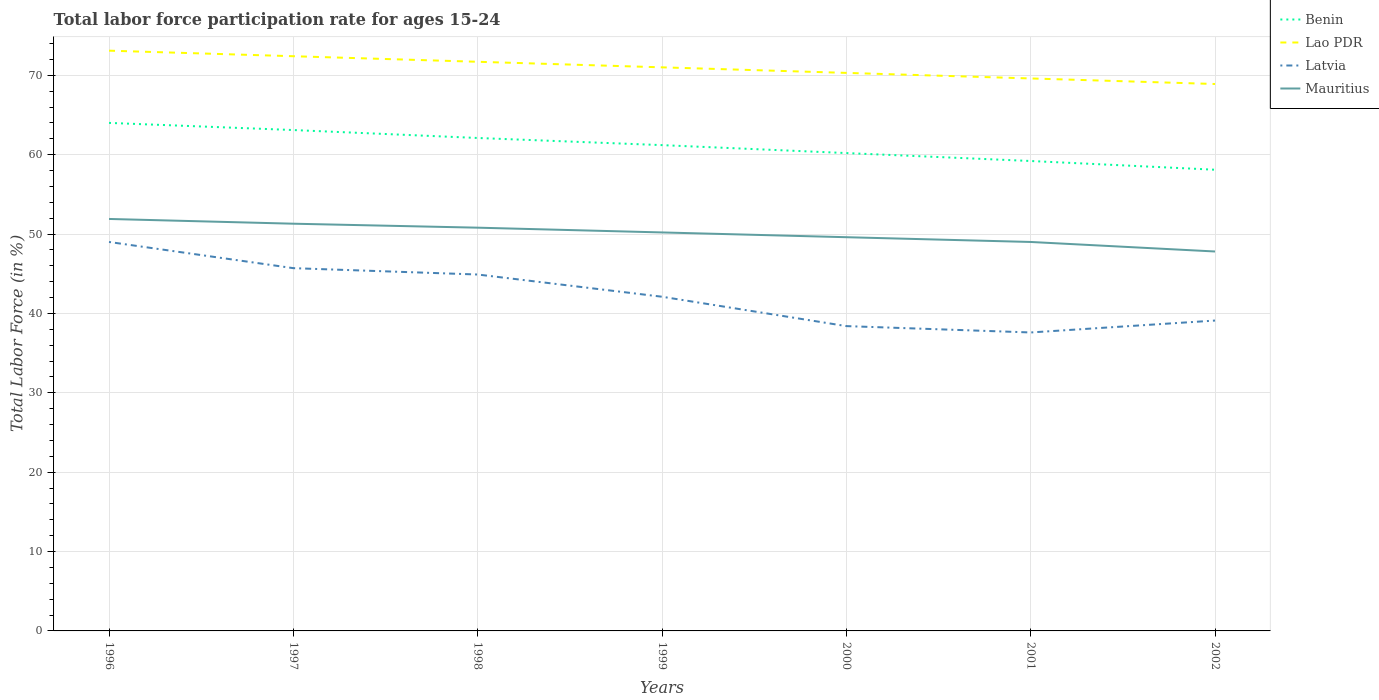How many different coloured lines are there?
Keep it short and to the point. 4. Is the number of lines equal to the number of legend labels?
Offer a terse response. Yes. Across all years, what is the maximum labor force participation rate in Latvia?
Ensure brevity in your answer.  37.6. What is the total labor force participation rate in Latvia in the graph?
Make the answer very short. 3. What is the difference between the highest and the second highest labor force participation rate in Benin?
Offer a terse response. 5.9. What is the difference between the highest and the lowest labor force participation rate in Latvia?
Offer a terse response. 3. Is the labor force participation rate in Lao PDR strictly greater than the labor force participation rate in Mauritius over the years?
Your answer should be very brief. No. How many lines are there?
Provide a succinct answer. 4. What is the difference between two consecutive major ticks on the Y-axis?
Keep it short and to the point. 10. Does the graph contain any zero values?
Make the answer very short. No. Does the graph contain grids?
Provide a succinct answer. Yes. How many legend labels are there?
Make the answer very short. 4. How are the legend labels stacked?
Your response must be concise. Vertical. What is the title of the graph?
Keep it short and to the point. Total labor force participation rate for ages 15-24. Does "Serbia" appear as one of the legend labels in the graph?
Your answer should be very brief. No. What is the label or title of the Y-axis?
Make the answer very short. Total Labor Force (in %). What is the Total Labor Force (in %) of Lao PDR in 1996?
Provide a succinct answer. 73.1. What is the Total Labor Force (in %) of Latvia in 1996?
Offer a very short reply. 49. What is the Total Labor Force (in %) in Mauritius in 1996?
Give a very brief answer. 51.9. What is the Total Labor Force (in %) of Benin in 1997?
Your response must be concise. 63.1. What is the Total Labor Force (in %) of Lao PDR in 1997?
Make the answer very short. 72.4. What is the Total Labor Force (in %) of Latvia in 1997?
Give a very brief answer. 45.7. What is the Total Labor Force (in %) of Mauritius in 1997?
Offer a terse response. 51.3. What is the Total Labor Force (in %) in Benin in 1998?
Your response must be concise. 62.1. What is the Total Labor Force (in %) in Lao PDR in 1998?
Offer a terse response. 71.7. What is the Total Labor Force (in %) of Latvia in 1998?
Keep it short and to the point. 44.9. What is the Total Labor Force (in %) of Mauritius in 1998?
Your response must be concise. 50.8. What is the Total Labor Force (in %) of Benin in 1999?
Give a very brief answer. 61.2. What is the Total Labor Force (in %) of Latvia in 1999?
Provide a short and direct response. 42.1. What is the Total Labor Force (in %) of Mauritius in 1999?
Keep it short and to the point. 50.2. What is the Total Labor Force (in %) in Benin in 2000?
Offer a very short reply. 60.2. What is the Total Labor Force (in %) of Lao PDR in 2000?
Keep it short and to the point. 70.3. What is the Total Labor Force (in %) in Latvia in 2000?
Keep it short and to the point. 38.4. What is the Total Labor Force (in %) in Mauritius in 2000?
Give a very brief answer. 49.6. What is the Total Labor Force (in %) of Benin in 2001?
Your answer should be very brief. 59.2. What is the Total Labor Force (in %) in Lao PDR in 2001?
Give a very brief answer. 69.6. What is the Total Labor Force (in %) of Latvia in 2001?
Provide a short and direct response. 37.6. What is the Total Labor Force (in %) in Mauritius in 2001?
Your answer should be very brief. 49. What is the Total Labor Force (in %) of Benin in 2002?
Provide a succinct answer. 58.1. What is the Total Labor Force (in %) in Lao PDR in 2002?
Provide a succinct answer. 68.9. What is the Total Labor Force (in %) in Latvia in 2002?
Provide a succinct answer. 39.1. What is the Total Labor Force (in %) in Mauritius in 2002?
Ensure brevity in your answer.  47.8. Across all years, what is the maximum Total Labor Force (in %) of Benin?
Give a very brief answer. 64. Across all years, what is the maximum Total Labor Force (in %) in Lao PDR?
Your response must be concise. 73.1. Across all years, what is the maximum Total Labor Force (in %) of Mauritius?
Provide a short and direct response. 51.9. Across all years, what is the minimum Total Labor Force (in %) of Benin?
Offer a terse response. 58.1. Across all years, what is the minimum Total Labor Force (in %) in Lao PDR?
Make the answer very short. 68.9. Across all years, what is the minimum Total Labor Force (in %) in Latvia?
Give a very brief answer. 37.6. Across all years, what is the minimum Total Labor Force (in %) of Mauritius?
Make the answer very short. 47.8. What is the total Total Labor Force (in %) of Benin in the graph?
Ensure brevity in your answer.  427.9. What is the total Total Labor Force (in %) of Lao PDR in the graph?
Offer a very short reply. 497. What is the total Total Labor Force (in %) in Latvia in the graph?
Offer a terse response. 296.8. What is the total Total Labor Force (in %) of Mauritius in the graph?
Provide a short and direct response. 350.6. What is the difference between the Total Labor Force (in %) of Benin in 1996 and that in 1998?
Ensure brevity in your answer.  1.9. What is the difference between the Total Labor Force (in %) of Lao PDR in 1996 and that in 1998?
Provide a short and direct response. 1.4. What is the difference between the Total Labor Force (in %) of Latvia in 1996 and that in 1998?
Make the answer very short. 4.1. What is the difference between the Total Labor Force (in %) of Benin in 1996 and that in 1999?
Keep it short and to the point. 2.8. What is the difference between the Total Labor Force (in %) in Mauritius in 1996 and that in 1999?
Ensure brevity in your answer.  1.7. What is the difference between the Total Labor Force (in %) in Benin in 1996 and that in 2000?
Provide a succinct answer. 3.8. What is the difference between the Total Labor Force (in %) in Mauritius in 1996 and that in 2000?
Your answer should be compact. 2.3. What is the difference between the Total Labor Force (in %) in Benin in 1997 and that in 1998?
Your answer should be very brief. 1. What is the difference between the Total Labor Force (in %) in Mauritius in 1997 and that in 1998?
Offer a terse response. 0.5. What is the difference between the Total Labor Force (in %) of Benin in 1997 and that in 1999?
Keep it short and to the point. 1.9. What is the difference between the Total Labor Force (in %) in Latvia in 1997 and that in 1999?
Provide a succinct answer. 3.6. What is the difference between the Total Labor Force (in %) of Mauritius in 1997 and that in 1999?
Ensure brevity in your answer.  1.1. What is the difference between the Total Labor Force (in %) of Benin in 1997 and that in 2000?
Give a very brief answer. 2.9. What is the difference between the Total Labor Force (in %) in Lao PDR in 1997 and that in 2001?
Give a very brief answer. 2.8. What is the difference between the Total Labor Force (in %) in Benin in 1997 and that in 2002?
Ensure brevity in your answer.  5. What is the difference between the Total Labor Force (in %) of Benin in 1998 and that in 1999?
Ensure brevity in your answer.  0.9. What is the difference between the Total Labor Force (in %) in Mauritius in 1998 and that in 1999?
Give a very brief answer. 0.6. What is the difference between the Total Labor Force (in %) in Lao PDR in 1998 and that in 2000?
Ensure brevity in your answer.  1.4. What is the difference between the Total Labor Force (in %) of Benin in 1998 and that in 2002?
Your response must be concise. 4. What is the difference between the Total Labor Force (in %) of Lao PDR in 1998 and that in 2002?
Offer a very short reply. 2.8. What is the difference between the Total Labor Force (in %) of Mauritius in 1998 and that in 2002?
Provide a short and direct response. 3. What is the difference between the Total Labor Force (in %) of Lao PDR in 1999 and that in 2000?
Your answer should be compact. 0.7. What is the difference between the Total Labor Force (in %) in Latvia in 1999 and that in 2000?
Your response must be concise. 3.7. What is the difference between the Total Labor Force (in %) of Mauritius in 1999 and that in 2000?
Provide a short and direct response. 0.6. What is the difference between the Total Labor Force (in %) in Benin in 1999 and that in 2001?
Provide a succinct answer. 2. What is the difference between the Total Labor Force (in %) in Lao PDR in 1999 and that in 2001?
Ensure brevity in your answer.  1.4. What is the difference between the Total Labor Force (in %) in Benin in 1999 and that in 2002?
Offer a terse response. 3.1. What is the difference between the Total Labor Force (in %) in Lao PDR in 1999 and that in 2002?
Make the answer very short. 2.1. What is the difference between the Total Labor Force (in %) in Latvia in 1999 and that in 2002?
Offer a terse response. 3. What is the difference between the Total Labor Force (in %) in Benin in 2000 and that in 2001?
Ensure brevity in your answer.  1. What is the difference between the Total Labor Force (in %) in Lao PDR in 2000 and that in 2001?
Keep it short and to the point. 0.7. What is the difference between the Total Labor Force (in %) in Latvia in 2000 and that in 2001?
Provide a succinct answer. 0.8. What is the difference between the Total Labor Force (in %) in Mauritius in 2000 and that in 2002?
Your answer should be very brief. 1.8. What is the difference between the Total Labor Force (in %) in Benin in 1996 and the Total Labor Force (in %) in Lao PDR in 1997?
Make the answer very short. -8.4. What is the difference between the Total Labor Force (in %) of Lao PDR in 1996 and the Total Labor Force (in %) of Latvia in 1997?
Provide a short and direct response. 27.4. What is the difference between the Total Labor Force (in %) of Lao PDR in 1996 and the Total Labor Force (in %) of Mauritius in 1997?
Provide a succinct answer. 21.8. What is the difference between the Total Labor Force (in %) in Latvia in 1996 and the Total Labor Force (in %) in Mauritius in 1997?
Your answer should be compact. -2.3. What is the difference between the Total Labor Force (in %) in Benin in 1996 and the Total Labor Force (in %) in Latvia in 1998?
Your answer should be very brief. 19.1. What is the difference between the Total Labor Force (in %) in Lao PDR in 1996 and the Total Labor Force (in %) in Latvia in 1998?
Ensure brevity in your answer.  28.2. What is the difference between the Total Labor Force (in %) of Lao PDR in 1996 and the Total Labor Force (in %) of Mauritius in 1998?
Keep it short and to the point. 22.3. What is the difference between the Total Labor Force (in %) of Benin in 1996 and the Total Labor Force (in %) of Lao PDR in 1999?
Your answer should be compact. -7. What is the difference between the Total Labor Force (in %) in Benin in 1996 and the Total Labor Force (in %) in Latvia in 1999?
Provide a succinct answer. 21.9. What is the difference between the Total Labor Force (in %) of Lao PDR in 1996 and the Total Labor Force (in %) of Mauritius in 1999?
Your answer should be very brief. 22.9. What is the difference between the Total Labor Force (in %) in Benin in 1996 and the Total Labor Force (in %) in Latvia in 2000?
Make the answer very short. 25.6. What is the difference between the Total Labor Force (in %) in Lao PDR in 1996 and the Total Labor Force (in %) in Latvia in 2000?
Ensure brevity in your answer.  34.7. What is the difference between the Total Labor Force (in %) of Lao PDR in 1996 and the Total Labor Force (in %) of Mauritius in 2000?
Keep it short and to the point. 23.5. What is the difference between the Total Labor Force (in %) in Latvia in 1996 and the Total Labor Force (in %) in Mauritius in 2000?
Offer a terse response. -0.6. What is the difference between the Total Labor Force (in %) of Benin in 1996 and the Total Labor Force (in %) of Latvia in 2001?
Make the answer very short. 26.4. What is the difference between the Total Labor Force (in %) of Benin in 1996 and the Total Labor Force (in %) of Mauritius in 2001?
Keep it short and to the point. 15. What is the difference between the Total Labor Force (in %) in Lao PDR in 1996 and the Total Labor Force (in %) in Latvia in 2001?
Ensure brevity in your answer.  35.5. What is the difference between the Total Labor Force (in %) in Lao PDR in 1996 and the Total Labor Force (in %) in Mauritius in 2001?
Your answer should be very brief. 24.1. What is the difference between the Total Labor Force (in %) of Latvia in 1996 and the Total Labor Force (in %) of Mauritius in 2001?
Your answer should be very brief. 0. What is the difference between the Total Labor Force (in %) in Benin in 1996 and the Total Labor Force (in %) in Lao PDR in 2002?
Give a very brief answer. -4.9. What is the difference between the Total Labor Force (in %) of Benin in 1996 and the Total Labor Force (in %) of Latvia in 2002?
Your answer should be compact. 24.9. What is the difference between the Total Labor Force (in %) in Lao PDR in 1996 and the Total Labor Force (in %) in Mauritius in 2002?
Offer a terse response. 25.3. What is the difference between the Total Labor Force (in %) in Benin in 1997 and the Total Labor Force (in %) in Lao PDR in 1998?
Give a very brief answer. -8.6. What is the difference between the Total Labor Force (in %) in Lao PDR in 1997 and the Total Labor Force (in %) in Latvia in 1998?
Ensure brevity in your answer.  27.5. What is the difference between the Total Labor Force (in %) in Lao PDR in 1997 and the Total Labor Force (in %) in Mauritius in 1998?
Your answer should be very brief. 21.6. What is the difference between the Total Labor Force (in %) of Benin in 1997 and the Total Labor Force (in %) of Lao PDR in 1999?
Give a very brief answer. -7.9. What is the difference between the Total Labor Force (in %) in Benin in 1997 and the Total Labor Force (in %) in Latvia in 1999?
Give a very brief answer. 21. What is the difference between the Total Labor Force (in %) in Benin in 1997 and the Total Labor Force (in %) in Mauritius in 1999?
Your answer should be compact. 12.9. What is the difference between the Total Labor Force (in %) of Lao PDR in 1997 and the Total Labor Force (in %) of Latvia in 1999?
Provide a succinct answer. 30.3. What is the difference between the Total Labor Force (in %) in Benin in 1997 and the Total Labor Force (in %) in Latvia in 2000?
Make the answer very short. 24.7. What is the difference between the Total Labor Force (in %) in Lao PDR in 1997 and the Total Labor Force (in %) in Mauritius in 2000?
Keep it short and to the point. 22.8. What is the difference between the Total Labor Force (in %) of Benin in 1997 and the Total Labor Force (in %) of Lao PDR in 2001?
Your response must be concise. -6.5. What is the difference between the Total Labor Force (in %) of Benin in 1997 and the Total Labor Force (in %) of Latvia in 2001?
Your response must be concise. 25.5. What is the difference between the Total Labor Force (in %) of Lao PDR in 1997 and the Total Labor Force (in %) of Latvia in 2001?
Offer a very short reply. 34.8. What is the difference between the Total Labor Force (in %) of Lao PDR in 1997 and the Total Labor Force (in %) of Mauritius in 2001?
Your answer should be very brief. 23.4. What is the difference between the Total Labor Force (in %) of Latvia in 1997 and the Total Labor Force (in %) of Mauritius in 2001?
Ensure brevity in your answer.  -3.3. What is the difference between the Total Labor Force (in %) in Benin in 1997 and the Total Labor Force (in %) in Lao PDR in 2002?
Ensure brevity in your answer.  -5.8. What is the difference between the Total Labor Force (in %) of Lao PDR in 1997 and the Total Labor Force (in %) of Latvia in 2002?
Provide a short and direct response. 33.3. What is the difference between the Total Labor Force (in %) in Lao PDR in 1997 and the Total Labor Force (in %) in Mauritius in 2002?
Keep it short and to the point. 24.6. What is the difference between the Total Labor Force (in %) in Latvia in 1997 and the Total Labor Force (in %) in Mauritius in 2002?
Offer a terse response. -2.1. What is the difference between the Total Labor Force (in %) of Benin in 1998 and the Total Labor Force (in %) of Mauritius in 1999?
Keep it short and to the point. 11.9. What is the difference between the Total Labor Force (in %) in Lao PDR in 1998 and the Total Labor Force (in %) in Latvia in 1999?
Make the answer very short. 29.6. What is the difference between the Total Labor Force (in %) in Lao PDR in 1998 and the Total Labor Force (in %) in Mauritius in 1999?
Keep it short and to the point. 21.5. What is the difference between the Total Labor Force (in %) in Benin in 1998 and the Total Labor Force (in %) in Latvia in 2000?
Your answer should be compact. 23.7. What is the difference between the Total Labor Force (in %) of Lao PDR in 1998 and the Total Labor Force (in %) of Latvia in 2000?
Offer a very short reply. 33.3. What is the difference between the Total Labor Force (in %) of Lao PDR in 1998 and the Total Labor Force (in %) of Mauritius in 2000?
Give a very brief answer. 22.1. What is the difference between the Total Labor Force (in %) of Benin in 1998 and the Total Labor Force (in %) of Latvia in 2001?
Your answer should be compact. 24.5. What is the difference between the Total Labor Force (in %) of Benin in 1998 and the Total Labor Force (in %) of Mauritius in 2001?
Keep it short and to the point. 13.1. What is the difference between the Total Labor Force (in %) of Lao PDR in 1998 and the Total Labor Force (in %) of Latvia in 2001?
Your answer should be very brief. 34.1. What is the difference between the Total Labor Force (in %) in Lao PDR in 1998 and the Total Labor Force (in %) in Mauritius in 2001?
Ensure brevity in your answer.  22.7. What is the difference between the Total Labor Force (in %) in Benin in 1998 and the Total Labor Force (in %) in Latvia in 2002?
Provide a succinct answer. 23. What is the difference between the Total Labor Force (in %) in Benin in 1998 and the Total Labor Force (in %) in Mauritius in 2002?
Keep it short and to the point. 14.3. What is the difference between the Total Labor Force (in %) in Lao PDR in 1998 and the Total Labor Force (in %) in Latvia in 2002?
Your answer should be compact. 32.6. What is the difference between the Total Labor Force (in %) of Lao PDR in 1998 and the Total Labor Force (in %) of Mauritius in 2002?
Ensure brevity in your answer.  23.9. What is the difference between the Total Labor Force (in %) in Benin in 1999 and the Total Labor Force (in %) in Latvia in 2000?
Give a very brief answer. 22.8. What is the difference between the Total Labor Force (in %) of Benin in 1999 and the Total Labor Force (in %) of Mauritius in 2000?
Offer a very short reply. 11.6. What is the difference between the Total Labor Force (in %) of Lao PDR in 1999 and the Total Labor Force (in %) of Latvia in 2000?
Your answer should be very brief. 32.6. What is the difference between the Total Labor Force (in %) in Lao PDR in 1999 and the Total Labor Force (in %) in Mauritius in 2000?
Make the answer very short. 21.4. What is the difference between the Total Labor Force (in %) of Benin in 1999 and the Total Labor Force (in %) of Latvia in 2001?
Your answer should be compact. 23.6. What is the difference between the Total Labor Force (in %) in Lao PDR in 1999 and the Total Labor Force (in %) in Latvia in 2001?
Ensure brevity in your answer.  33.4. What is the difference between the Total Labor Force (in %) of Latvia in 1999 and the Total Labor Force (in %) of Mauritius in 2001?
Ensure brevity in your answer.  -6.9. What is the difference between the Total Labor Force (in %) in Benin in 1999 and the Total Labor Force (in %) in Latvia in 2002?
Provide a short and direct response. 22.1. What is the difference between the Total Labor Force (in %) in Benin in 1999 and the Total Labor Force (in %) in Mauritius in 2002?
Your response must be concise. 13.4. What is the difference between the Total Labor Force (in %) of Lao PDR in 1999 and the Total Labor Force (in %) of Latvia in 2002?
Your answer should be compact. 31.9. What is the difference between the Total Labor Force (in %) of Lao PDR in 1999 and the Total Labor Force (in %) of Mauritius in 2002?
Ensure brevity in your answer.  23.2. What is the difference between the Total Labor Force (in %) of Benin in 2000 and the Total Labor Force (in %) of Latvia in 2001?
Your response must be concise. 22.6. What is the difference between the Total Labor Force (in %) of Benin in 2000 and the Total Labor Force (in %) of Mauritius in 2001?
Provide a succinct answer. 11.2. What is the difference between the Total Labor Force (in %) of Lao PDR in 2000 and the Total Labor Force (in %) of Latvia in 2001?
Offer a very short reply. 32.7. What is the difference between the Total Labor Force (in %) in Lao PDR in 2000 and the Total Labor Force (in %) in Mauritius in 2001?
Your answer should be compact. 21.3. What is the difference between the Total Labor Force (in %) in Latvia in 2000 and the Total Labor Force (in %) in Mauritius in 2001?
Offer a very short reply. -10.6. What is the difference between the Total Labor Force (in %) of Benin in 2000 and the Total Labor Force (in %) of Lao PDR in 2002?
Make the answer very short. -8.7. What is the difference between the Total Labor Force (in %) of Benin in 2000 and the Total Labor Force (in %) of Latvia in 2002?
Offer a very short reply. 21.1. What is the difference between the Total Labor Force (in %) in Benin in 2000 and the Total Labor Force (in %) in Mauritius in 2002?
Offer a very short reply. 12.4. What is the difference between the Total Labor Force (in %) in Lao PDR in 2000 and the Total Labor Force (in %) in Latvia in 2002?
Your response must be concise. 31.2. What is the difference between the Total Labor Force (in %) in Latvia in 2000 and the Total Labor Force (in %) in Mauritius in 2002?
Give a very brief answer. -9.4. What is the difference between the Total Labor Force (in %) of Benin in 2001 and the Total Labor Force (in %) of Lao PDR in 2002?
Make the answer very short. -9.7. What is the difference between the Total Labor Force (in %) in Benin in 2001 and the Total Labor Force (in %) in Latvia in 2002?
Keep it short and to the point. 20.1. What is the difference between the Total Labor Force (in %) of Benin in 2001 and the Total Labor Force (in %) of Mauritius in 2002?
Provide a short and direct response. 11.4. What is the difference between the Total Labor Force (in %) in Lao PDR in 2001 and the Total Labor Force (in %) in Latvia in 2002?
Offer a terse response. 30.5. What is the difference between the Total Labor Force (in %) in Lao PDR in 2001 and the Total Labor Force (in %) in Mauritius in 2002?
Keep it short and to the point. 21.8. What is the average Total Labor Force (in %) in Benin per year?
Ensure brevity in your answer.  61.13. What is the average Total Labor Force (in %) of Lao PDR per year?
Provide a short and direct response. 71. What is the average Total Labor Force (in %) in Latvia per year?
Make the answer very short. 42.4. What is the average Total Labor Force (in %) in Mauritius per year?
Provide a succinct answer. 50.09. In the year 1996, what is the difference between the Total Labor Force (in %) in Benin and Total Labor Force (in %) in Mauritius?
Your answer should be very brief. 12.1. In the year 1996, what is the difference between the Total Labor Force (in %) of Lao PDR and Total Labor Force (in %) of Latvia?
Your response must be concise. 24.1. In the year 1996, what is the difference between the Total Labor Force (in %) in Lao PDR and Total Labor Force (in %) in Mauritius?
Make the answer very short. 21.2. In the year 1996, what is the difference between the Total Labor Force (in %) in Latvia and Total Labor Force (in %) in Mauritius?
Your answer should be compact. -2.9. In the year 1997, what is the difference between the Total Labor Force (in %) of Benin and Total Labor Force (in %) of Lao PDR?
Ensure brevity in your answer.  -9.3. In the year 1997, what is the difference between the Total Labor Force (in %) of Benin and Total Labor Force (in %) of Latvia?
Provide a short and direct response. 17.4. In the year 1997, what is the difference between the Total Labor Force (in %) in Benin and Total Labor Force (in %) in Mauritius?
Provide a succinct answer. 11.8. In the year 1997, what is the difference between the Total Labor Force (in %) of Lao PDR and Total Labor Force (in %) of Latvia?
Your response must be concise. 26.7. In the year 1997, what is the difference between the Total Labor Force (in %) of Lao PDR and Total Labor Force (in %) of Mauritius?
Offer a terse response. 21.1. In the year 1998, what is the difference between the Total Labor Force (in %) of Benin and Total Labor Force (in %) of Lao PDR?
Provide a short and direct response. -9.6. In the year 1998, what is the difference between the Total Labor Force (in %) in Benin and Total Labor Force (in %) in Latvia?
Provide a succinct answer. 17.2. In the year 1998, what is the difference between the Total Labor Force (in %) of Lao PDR and Total Labor Force (in %) of Latvia?
Provide a short and direct response. 26.8. In the year 1998, what is the difference between the Total Labor Force (in %) of Lao PDR and Total Labor Force (in %) of Mauritius?
Your answer should be very brief. 20.9. In the year 1999, what is the difference between the Total Labor Force (in %) of Benin and Total Labor Force (in %) of Latvia?
Ensure brevity in your answer.  19.1. In the year 1999, what is the difference between the Total Labor Force (in %) of Benin and Total Labor Force (in %) of Mauritius?
Your answer should be very brief. 11. In the year 1999, what is the difference between the Total Labor Force (in %) in Lao PDR and Total Labor Force (in %) in Latvia?
Provide a succinct answer. 28.9. In the year 1999, what is the difference between the Total Labor Force (in %) of Lao PDR and Total Labor Force (in %) of Mauritius?
Your answer should be very brief. 20.8. In the year 2000, what is the difference between the Total Labor Force (in %) in Benin and Total Labor Force (in %) in Lao PDR?
Provide a succinct answer. -10.1. In the year 2000, what is the difference between the Total Labor Force (in %) in Benin and Total Labor Force (in %) in Latvia?
Provide a short and direct response. 21.8. In the year 2000, what is the difference between the Total Labor Force (in %) of Lao PDR and Total Labor Force (in %) of Latvia?
Your answer should be very brief. 31.9. In the year 2000, what is the difference between the Total Labor Force (in %) in Lao PDR and Total Labor Force (in %) in Mauritius?
Your answer should be compact. 20.7. In the year 2000, what is the difference between the Total Labor Force (in %) of Latvia and Total Labor Force (in %) of Mauritius?
Offer a terse response. -11.2. In the year 2001, what is the difference between the Total Labor Force (in %) of Benin and Total Labor Force (in %) of Latvia?
Give a very brief answer. 21.6. In the year 2001, what is the difference between the Total Labor Force (in %) of Benin and Total Labor Force (in %) of Mauritius?
Provide a succinct answer. 10.2. In the year 2001, what is the difference between the Total Labor Force (in %) of Lao PDR and Total Labor Force (in %) of Mauritius?
Offer a very short reply. 20.6. In the year 2002, what is the difference between the Total Labor Force (in %) in Benin and Total Labor Force (in %) in Mauritius?
Give a very brief answer. 10.3. In the year 2002, what is the difference between the Total Labor Force (in %) of Lao PDR and Total Labor Force (in %) of Latvia?
Ensure brevity in your answer.  29.8. In the year 2002, what is the difference between the Total Labor Force (in %) of Lao PDR and Total Labor Force (in %) of Mauritius?
Provide a succinct answer. 21.1. What is the ratio of the Total Labor Force (in %) of Benin in 1996 to that in 1997?
Your answer should be very brief. 1.01. What is the ratio of the Total Labor Force (in %) in Lao PDR in 1996 to that in 1997?
Make the answer very short. 1.01. What is the ratio of the Total Labor Force (in %) in Latvia in 1996 to that in 1997?
Give a very brief answer. 1.07. What is the ratio of the Total Labor Force (in %) of Mauritius in 1996 to that in 1997?
Your response must be concise. 1.01. What is the ratio of the Total Labor Force (in %) in Benin in 1996 to that in 1998?
Offer a very short reply. 1.03. What is the ratio of the Total Labor Force (in %) of Lao PDR in 1996 to that in 1998?
Provide a succinct answer. 1.02. What is the ratio of the Total Labor Force (in %) in Latvia in 1996 to that in 1998?
Provide a short and direct response. 1.09. What is the ratio of the Total Labor Force (in %) in Mauritius in 1996 to that in 1998?
Keep it short and to the point. 1.02. What is the ratio of the Total Labor Force (in %) in Benin in 1996 to that in 1999?
Your answer should be compact. 1.05. What is the ratio of the Total Labor Force (in %) of Lao PDR in 1996 to that in 1999?
Keep it short and to the point. 1.03. What is the ratio of the Total Labor Force (in %) of Latvia in 1996 to that in 1999?
Your response must be concise. 1.16. What is the ratio of the Total Labor Force (in %) of Mauritius in 1996 to that in 1999?
Give a very brief answer. 1.03. What is the ratio of the Total Labor Force (in %) of Benin in 1996 to that in 2000?
Keep it short and to the point. 1.06. What is the ratio of the Total Labor Force (in %) in Lao PDR in 1996 to that in 2000?
Make the answer very short. 1.04. What is the ratio of the Total Labor Force (in %) in Latvia in 1996 to that in 2000?
Provide a short and direct response. 1.28. What is the ratio of the Total Labor Force (in %) of Mauritius in 1996 to that in 2000?
Your answer should be very brief. 1.05. What is the ratio of the Total Labor Force (in %) in Benin in 1996 to that in 2001?
Offer a very short reply. 1.08. What is the ratio of the Total Labor Force (in %) of Lao PDR in 1996 to that in 2001?
Offer a terse response. 1.05. What is the ratio of the Total Labor Force (in %) in Latvia in 1996 to that in 2001?
Make the answer very short. 1.3. What is the ratio of the Total Labor Force (in %) of Mauritius in 1996 to that in 2001?
Your response must be concise. 1.06. What is the ratio of the Total Labor Force (in %) in Benin in 1996 to that in 2002?
Provide a succinct answer. 1.1. What is the ratio of the Total Labor Force (in %) of Lao PDR in 1996 to that in 2002?
Ensure brevity in your answer.  1.06. What is the ratio of the Total Labor Force (in %) in Latvia in 1996 to that in 2002?
Your answer should be very brief. 1.25. What is the ratio of the Total Labor Force (in %) in Mauritius in 1996 to that in 2002?
Provide a short and direct response. 1.09. What is the ratio of the Total Labor Force (in %) of Benin in 1997 to that in 1998?
Offer a very short reply. 1.02. What is the ratio of the Total Labor Force (in %) in Lao PDR in 1997 to that in 1998?
Make the answer very short. 1.01. What is the ratio of the Total Labor Force (in %) in Latvia in 1997 to that in 1998?
Your answer should be very brief. 1.02. What is the ratio of the Total Labor Force (in %) in Mauritius in 1997 to that in 1998?
Your answer should be very brief. 1.01. What is the ratio of the Total Labor Force (in %) in Benin in 1997 to that in 1999?
Your answer should be compact. 1.03. What is the ratio of the Total Labor Force (in %) in Lao PDR in 1997 to that in 1999?
Your response must be concise. 1.02. What is the ratio of the Total Labor Force (in %) in Latvia in 1997 to that in 1999?
Give a very brief answer. 1.09. What is the ratio of the Total Labor Force (in %) in Mauritius in 1997 to that in 1999?
Your response must be concise. 1.02. What is the ratio of the Total Labor Force (in %) in Benin in 1997 to that in 2000?
Provide a succinct answer. 1.05. What is the ratio of the Total Labor Force (in %) of Lao PDR in 1997 to that in 2000?
Offer a terse response. 1.03. What is the ratio of the Total Labor Force (in %) in Latvia in 1997 to that in 2000?
Make the answer very short. 1.19. What is the ratio of the Total Labor Force (in %) in Mauritius in 1997 to that in 2000?
Your response must be concise. 1.03. What is the ratio of the Total Labor Force (in %) in Benin in 1997 to that in 2001?
Provide a succinct answer. 1.07. What is the ratio of the Total Labor Force (in %) in Lao PDR in 1997 to that in 2001?
Your response must be concise. 1.04. What is the ratio of the Total Labor Force (in %) in Latvia in 1997 to that in 2001?
Ensure brevity in your answer.  1.22. What is the ratio of the Total Labor Force (in %) of Mauritius in 1997 to that in 2001?
Provide a short and direct response. 1.05. What is the ratio of the Total Labor Force (in %) of Benin in 1997 to that in 2002?
Your answer should be compact. 1.09. What is the ratio of the Total Labor Force (in %) of Lao PDR in 1997 to that in 2002?
Your answer should be compact. 1.05. What is the ratio of the Total Labor Force (in %) in Latvia in 1997 to that in 2002?
Your response must be concise. 1.17. What is the ratio of the Total Labor Force (in %) of Mauritius in 1997 to that in 2002?
Give a very brief answer. 1.07. What is the ratio of the Total Labor Force (in %) of Benin in 1998 to that in 1999?
Make the answer very short. 1.01. What is the ratio of the Total Labor Force (in %) in Lao PDR in 1998 to that in 1999?
Give a very brief answer. 1.01. What is the ratio of the Total Labor Force (in %) of Latvia in 1998 to that in 1999?
Provide a succinct answer. 1.07. What is the ratio of the Total Labor Force (in %) of Benin in 1998 to that in 2000?
Ensure brevity in your answer.  1.03. What is the ratio of the Total Labor Force (in %) in Lao PDR in 1998 to that in 2000?
Ensure brevity in your answer.  1.02. What is the ratio of the Total Labor Force (in %) in Latvia in 1998 to that in 2000?
Your answer should be compact. 1.17. What is the ratio of the Total Labor Force (in %) of Mauritius in 1998 to that in 2000?
Provide a succinct answer. 1.02. What is the ratio of the Total Labor Force (in %) in Benin in 1998 to that in 2001?
Make the answer very short. 1.05. What is the ratio of the Total Labor Force (in %) of Lao PDR in 1998 to that in 2001?
Make the answer very short. 1.03. What is the ratio of the Total Labor Force (in %) of Latvia in 1998 to that in 2001?
Provide a short and direct response. 1.19. What is the ratio of the Total Labor Force (in %) of Mauritius in 1998 to that in 2001?
Ensure brevity in your answer.  1.04. What is the ratio of the Total Labor Force (in %) in Benin in 1998 to that in 2002?
Your response must be concise. 1.07. What is the ratio of the Total Labor Force (in %) in Lao PDR in 1998 to that in 2002?
Give a very brief answer. 1.04. What is the ratio of the Total Labor Force (in %) in Latvia in 1998 to that in 2002?
Keep it short and to the point. 1.15. What is the ratio of the Total Labor Force (in %) in Mauritius in 1998 to that in 2002?
Your answer should be compact. 1.06. What is the ratio of the Total Labor Force (in %) in Benin in 1999 to that in 2000?
Your answer should be very brief. 1.02. What is the ratio of the Total Labor Force (in %) in Lao PDR in 1999 to that in 2000?
Provide a succinct answer. 1.01. What is the ratio of the Total Labor Force (in %) in Latvia in 1999 to that in 2000?
Ensure brevity in your answer.  1.1. What is the ratio of the Total Labor Force (in %) of Mauritius in 1999 to that in 2000?
Your answer should be very brief. 1.01. What is the ratio of the Total Labor Force (in %) of Benin in 1999 to that in 2001?
Offer a very short reply. 1.03. What is the ratio of the Total Labor Force (in %) in Lao PDR in 1999 to that in 2001?
Your answer should be very brief. 1.02. What is the ratio of the Total Labor Force (in %) of Latvia in 1999 to that in 2001?
Your answer should be compact. 1.12. What is the ratio of the Total Labor Force (in %) in Mauritius in 1999 to that in 2001?
Offer a very short reply. 1.02. What is the ratio of the Total Labor Force (in %) in Benin in 1999 to that in 2002?
Ensure brevity in your answer.  1.05. What is the ratio of the Total Labor Force (in %) in Lao PDR in 1999 to that in 2002?
Offer a very short reply. 1.03. What is the ratio of the Total Labor Force (in %) in Latvia in 1999 to that in 2002?
Your answer should be compact. 1.08. What is the ratio of the Total Labor Force (in %) in Mauritius in 1999 to that in 2002?
Your answer should be very brief. 1.05. What is the ratio of the Total Labor Force (in %) in Benin in 2000 to that in 2001?
Keep it short and to the point. 1.02. What is the ratio of the Total Labor Force (in %) in Lao PDR in 2000 to that in 2001?
Provide a succinct answer. 1.01. What is the ratio of the Total Labor Force (in %) in Latvia in 2000 to that in 2001?
Offer a terse response. 1.02. What is the ratio of the Total Labor Force (in %) in Mauritius in 2000 to that in 2001?
Give a very brief answer. 1.01. What is the ratio of the Total Labor Force (in %) in Benin in 2000 to that in 2002?
Your answer should be very brief. 1.04. What is the ratio of the Total Labor Force (in %) in Lao PDR in 2000 to that in 2002?
Your response must be concise. 1.02. What is the ratio of the Total Labor Force (in %) of Latvia in 2000 to that in 2002?
Offer a very short reply. 0.98. What is the ratio of the Total Labor Force (in %) in Mauritius in 2000 to that in 2002?
Provide a succinct answer. 1.04. What is the ratio of the Total Labor Force (in %) of Benin in 2001 to that in 2002?
Give a very brief answer. 1.02. What is the ratio of the Total Labor Force (in %) in Lao PDR in 2001 to that in 2002?
Offer a very short reply. 1.01. What is the ratio of the Total Labor Force (in %) in Latvia in 2001 to that in 2002?
Offer a very short reply. 0.96. What is the ratio of the Total Labor Force (in %) in Mauritius in 2001 to that in 2002?
Offer a terse response. 1.03. What is the difference between the highest and the lowest Total Labor Force (in %) in Lao PDR?
Provide a succinct answer. 4.2. What is the difference between the highest and the lowest Total Labor Force (in %) of Mauritius?
Provide a short and direct response. 4.1. 